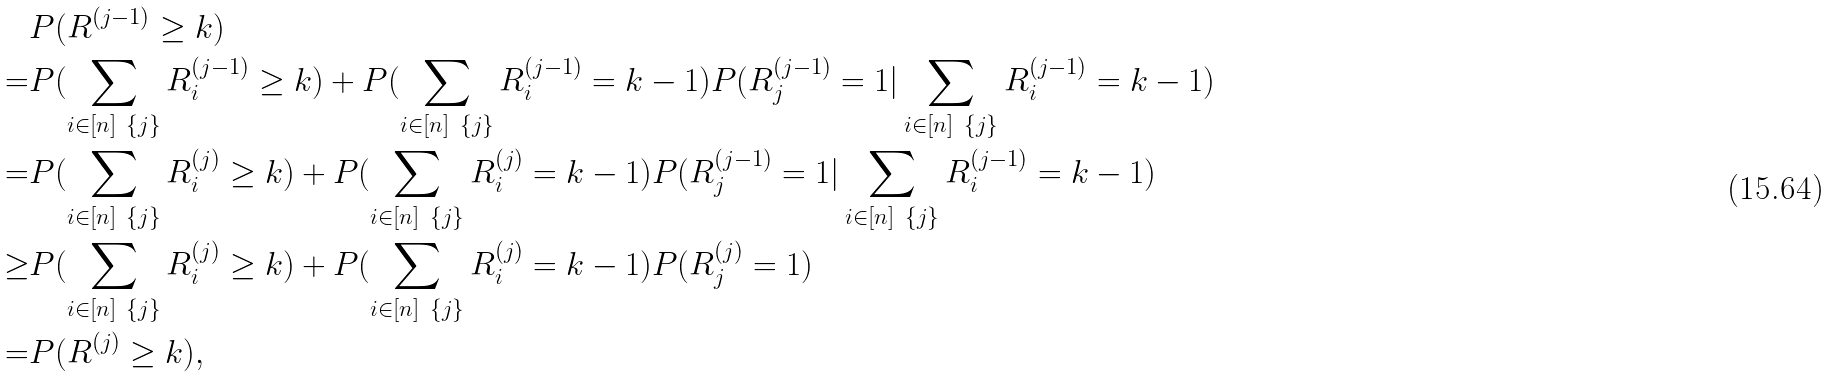<formula> <loc_0><loc_0><loc_500><loc_500>& P ( R ^ { ( j - 1 ) } \geq k ) \\ = & P ( \sum _ { i \in [ n ] \ \{ j \} } R _ { i } ^ { ( j - 1 ) } \geq k ) + P ( \sum _ { i \in [ n ] \ \{ j \} } R _ { i } ^ { ( j - 1 ) } = k - 1 ) P ( R _ { j } ^ { ( j - 1 ) } = 1 | \sum _ { i \in [ n ] \ \{ j \} } R _ { i } ^ { ( j - 1 ) } = k - 1 ) \\ = & P ( \sum _ { i \in [ n ] \ \{ j \} } R _ { i } ^ { ( j ) } \geq k ) + P ( \sum _ { i \in [ n ] \ \{ j \} } R _ { i } ^ { ( j ) } = k - 1 ) P ( R _ { j } ^ { ( j - 1 ) } = 1 | \sum _ { i \in [ n ] \ \{ j \} } R _ { i } ^ { ( j - 1 ) } = k - 1 ) \\ \geq & P ( \sum _ { i \in [ n ] \ \{ j \} } R _ { i } ^ { ( j ) } \geq k ) + P ( \sum _ { i \in [ n ] \ \{ j \} } R _ { i } ^ { ( j ) } = k - 1 ) P ( R _ { j } ^ { ( j ) } = 1 ) \\ = & P ( R ^ { ( j ) } \geq k ) ,</formula> 